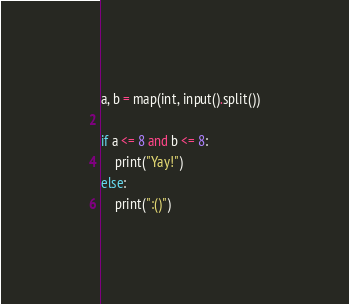Convert code to text. <code><loc_0><loc_0><loc_500><loc_500><_Python_>a, b = map(int, input().split())

if a <= 8 and b <= 8:
    print("Yay!")
else:
    print(":()")</code> 